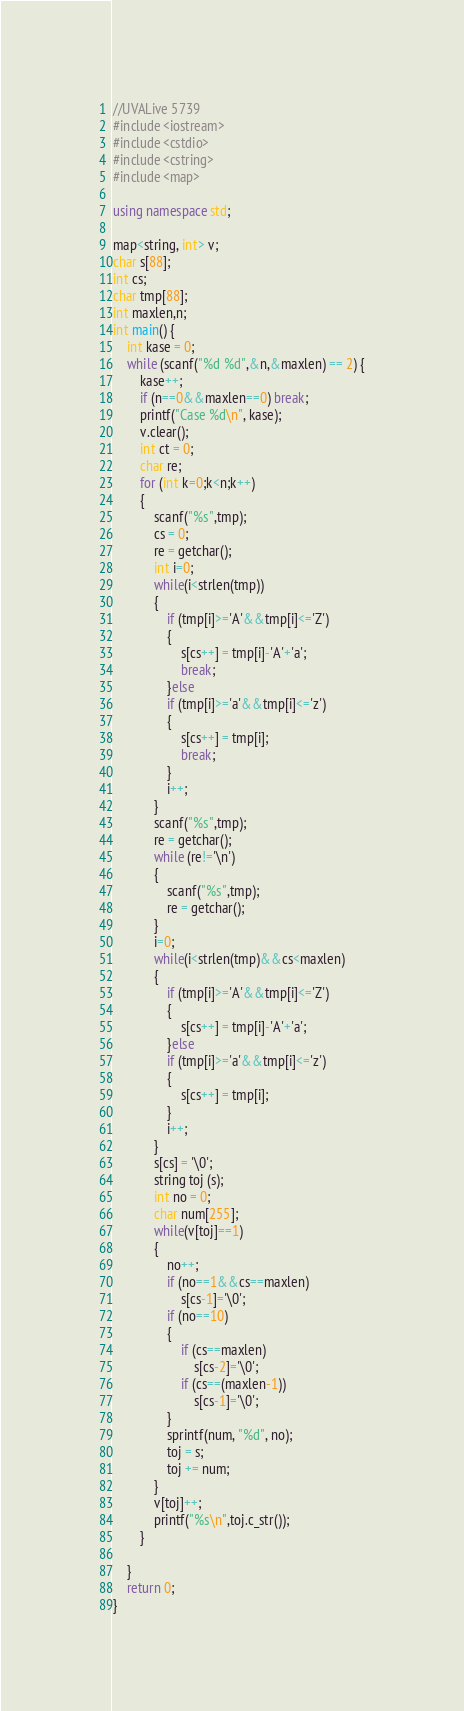Convert code to text. <code><loc_0><loc_0><loc_500><loc_500><_C++_>//UVALive 5739
#include <iostream>
#include <cstdio>
#include <cstring>
#include <map>

using namespace std;

map<string, int> v;
char s[88];
int cs;
char tmp[88];
int maxlen,n;
int main() {
    int kase = 0;
    while (scanf("%d %d",&n,&maxlen) == 2) {
        kase++;
        if (n==0&&maxlen==0) break;
        printf("Case %d\n", kase);
        v.clear();
        int ct = 0;
        char re;
        for (int k=0;k<n;k++)
        {
            scanf("%s",tmp);
            cs = 0;
            re = getchar();
            int i=0;
            while(i<strlen(tmp))
            {
                if (tmp[i]>='A'&&tmp[i]<='Z')
                {
                    s[cs++] = tmp[i]-'A'+'a';
                    break;
                }else
                if (tmp[i]>='a'&&tmp[i]<='z')
                {
                    s[cs++] = tmp[i];
                    break;
                }
                i++;
            }
            scanf("%s",tmp);
            re = getchar();
            while (re!='\n')
            {
                scanf("%s",tmp);
                re = getchar();
            }
            i=0;
            while(i<strlen(tmp)&&cs<maxlen)
            {
                if (tmp[i]>='A'&&tmp[i]<='Z')
                {
                    s[cs++] = tmp[i]-'A'+'a';
                }else
                if (tmp[i]>='a'&&tmp[i]<='z')
                {
                    s[cs++] = tmp[i];
                }
                i++;
            }
            s[cs] = '\0';
            string toj (s);
            int no = 0;
            char num[255];
            while(v[toj]==1)
            {
                no++;
                if (no==1&&cs==maxlen)
                    s[cs-1]='\0';
                if (no==10)
                {
                    if (cs==maxlen)
                        s[cs-2]='\0';
                    if (cs==(maxlen-1))
                        s[cs-1]='\0';
                }
                sprintf(num, "%d", no);
                toj = s;
                toj += num;
            }
            v[toj]++;
            printf("%s\n",toj.c_str());
        }

    }
    return 0;
}
</code> 